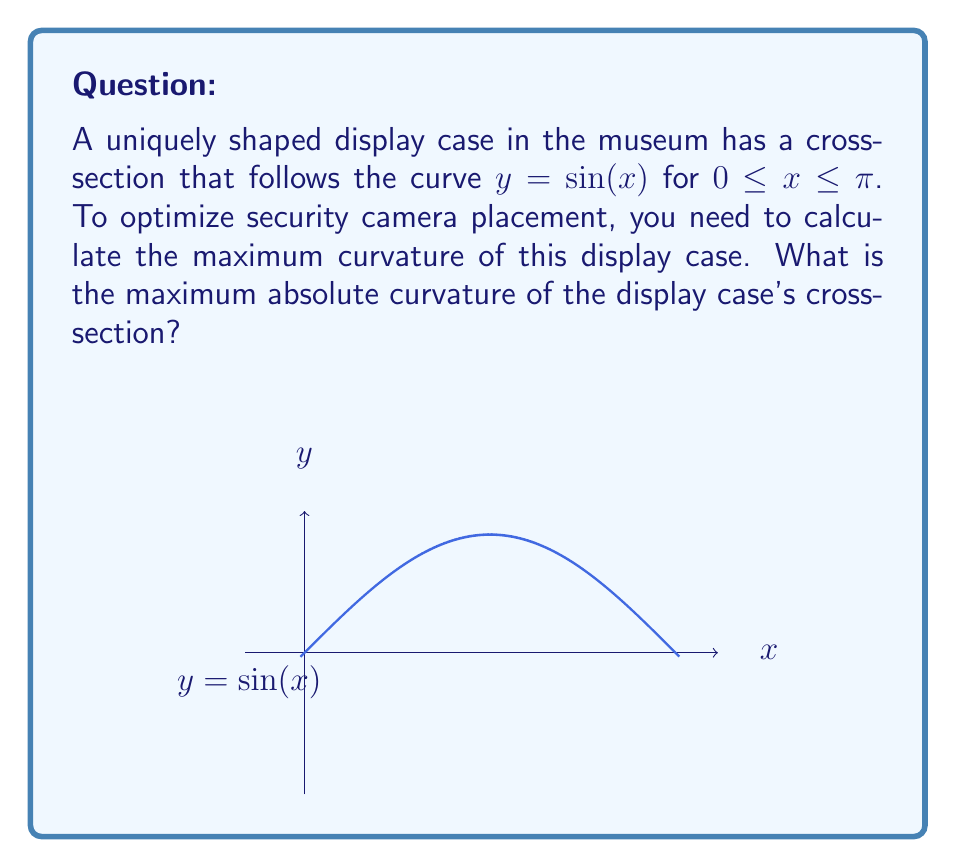Provide a solution to this math problem. To find the maximum curvature of the display case, we'll follow these steps:

1) The curvature of a function $y = f(x)$ is given by the formula:

   $$\kappa = \frac{|f''(x)|}{(1 + [f'(x)]^2)^{3/2}}$$

2) For $y = \sin(x)$, we need to find $f'(x)$ and $f''(x)$:
   
   $f'(x) = \cos(x)$
   $f''(x) = -\sin(x)$

3) Substituting into the curvature formula:

   $$\kappa = \frac{|\sin(x)|}{(1 + [\cos(x)]^2)^{3/2}}$$

4) To find the maximum, we can consider the absolute value of $\kappa$:

   $$|\kappa| = \frac{|\sin(x)|}{(1 + [\cos(x)]^2)^{3/2}}$$

5) The maximum value will occur when $|\sin(x)| = 1$ and $\cos(x) = 0$, which happens at $x = \frac{\pi}{2}$.

6) Substituting $x = \frac{\pi}{2}$ into the curvature formula:

   $$|\kappa|_{max} = \frac{|\sin(\frac{\pi}{2})|}{(1 + [\cos(\frac{\pi}{2})]^2)^{3/2}} = \frac{1}{(1 + 0^2)^{3/2}} = 1$$

Therefore, the maximum absolute curvature of the display case's cross-section is 1.
Answer: 1 